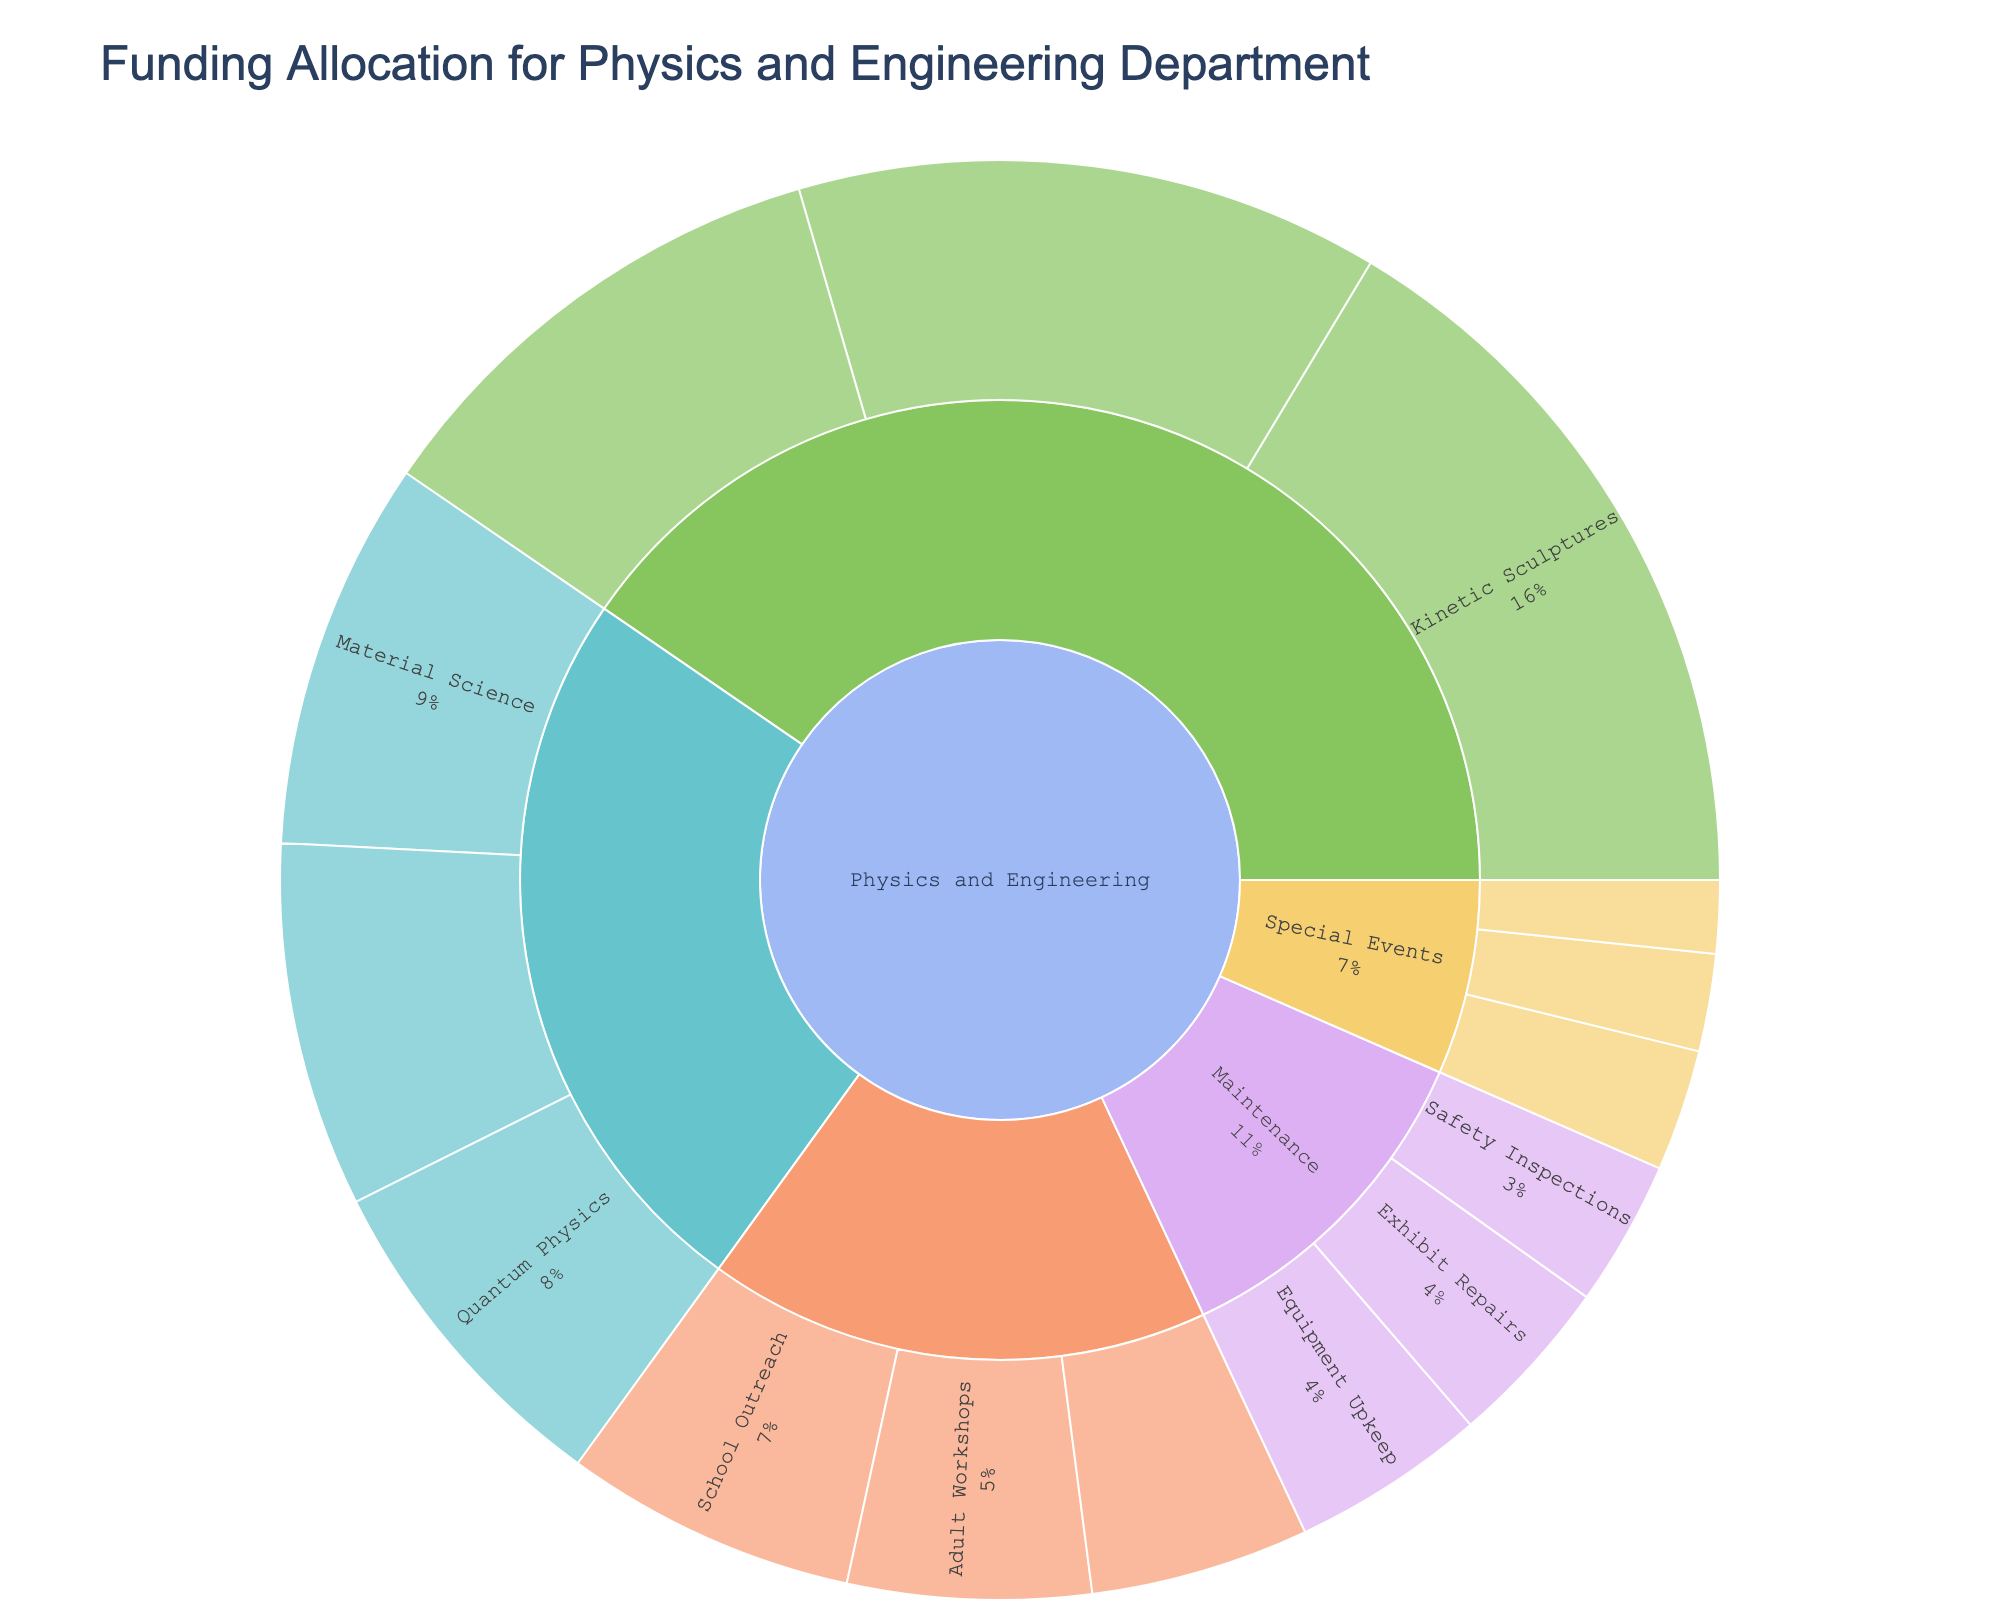What is the total funding allocation for Interactive Exhibits? Sum the allocations for Kinetic Sculptures, Hands-on Experiments, and Virtual Reality Simulations within the Interactive Exhibits category: $150,000 + $120,000 + $100,000 = $370,000
Answer: $370,000 Which subcategory in Physics and Engineering has the highest allocation? Kinetic Sculptures within the Interactive Exhibits category has the highest allocation at $150,000
Answer: Kinetic Sculptures How does the allocation for Mechanical Engineering compare to Quantum Physics? Mechanical Engineering has an allocation of $75,000 while Quantum Physics has an allocation of $70,000 within the Research and Development category, meaning Mechanical Engineering has $5,000 more
Answer: Mechanical Engineering What is the smallest funding allocation in the Special Events category? Physics Film Screenings within Special Events has the smallest allocation at $15,000
Answer: Physics Film Screenings How much more funding does School Outreach receive compared to Adult Workshops? School Outreach has $60,000, and Adult Workshops have $50,000. The difference is $60,000 - $50,000 = $10,000
Answer: $10,000 If the funding for Equipment Upkeep and Exhibit Repairs are combined, what would be their total? Sum the allocations for Equipment Upkeep and Exhibit Repairs within the Maintenance category: $40,000 + $35,000 = $75,000
Answer: $75,000 Which category has the second-highest total funding allocation within Physics and Engineering? Add up allocations for Interactive Exhibits, Research and Development, Educational Programs, Maintenance, and Special Events: Interactive Exhibits - $370,000, Research and Development - $225,000, Educational Programs - $155,000, Maintenance - $105,000, Special Events - $55,000. Research and Development has the second-highest at $225,000
Answer: Research and Development What percentage of the total funding is allocated to Virtual Reality Simulations? Calculate the total funding and find the percentage: $1,450,000. The allocation for Virtual Reality Simulations is $100,000. Percentage = ($100,000 / $1,450,000) * 100 ≈ 6.90%
Answer: 6.90% Which subcategory in Physics and Engineering has an allocation of $35,000? Exhibit Repairs within the Maintenance category has an allocation of $35,000
Answer: Exhibit Repairs What portion of the total allocation is directed towards Special Events compared to total funding? The total funding is $1,450,000. The allocation for Special Events is $55,000. Portion = $55,000 / $1,450,000 ≈ 0.038
Answer: 0.038 